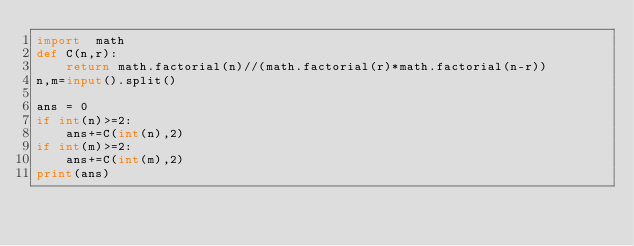Convert code to text. <code><loc_0><loc_0><loc_500><loc_500><_Python_>import  math
def C(n,r):
    return math.factorial(n)//(math.factorial(r)*math.factorial(n-r))
n,m=input().split()

ans = 0
if int(n)>=2:
    ans+=C(int(n),2)
if int(m)>=2:
    ans+=C(int(m),2)
print(ans)</code> 